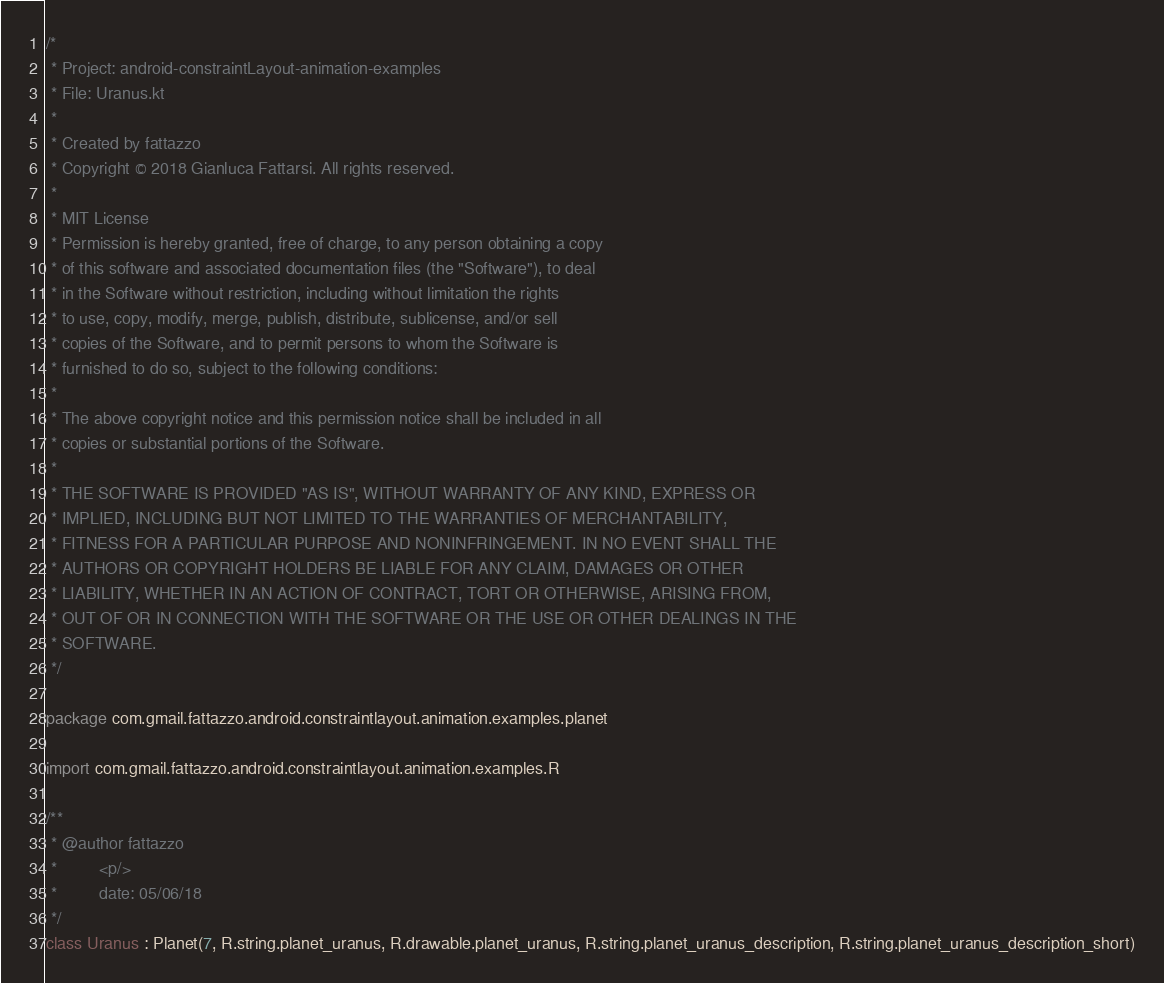Convert code to text. <code><loc_0><loc_0><loc_500><loc_500><_Kotlin_>/*
 * Project: android-constraintLayout-animation-examples
 * File: Uranus.kt
 *
 * Created by fattazzo
 * Copyright © 2018 Gianluca Fattarsi. All rights reserved.
 *
 * MIT License
 * Permission is hereby granted, free of charge, to any person obtaining a copy
 * of this software and associated documentation files (the "Software"), to deal
 * in the Software without restriction, including without limitation the rights
 * to use, copy, modify, merge, publish, distribute, sublicense, and/or sell
 * copies of the Software, and to permit persons to whom the Software is
 * furnished to do so, subject to the following conditions:
 *
 * The above copyright notice and this permission notice shall be included in all
 * copies or substantial portions of the Software.
 *
 * THE SOFTWARE IS PROVIDED "AS IS", WITHOUT WARRANTY OF ANY KIND, EXPRESS OR
 * IMPLIED, INCLUDING BUT NOT LIMITED TO THE WARRANTIES OF MERCHANTABILITY,
 * FITNESS FOR A PARTICULAR PURPOSE AND NONINFRINGEMENT. IN NO EVENT SHALL THE
 * AUTHORS OR COPYRIGHT HOLDERS BE LIABLE FOR ANY CLAIM, DAMAGES OR OTHER
 * LIABILITY, WHETHER IN AN ACTION OF CONTRACT, TORT OR OTHERWISE, ARISING FROM,
 * OUT OF OR IN CONNECTION WITH THE SOFTWARE OR THE USE OR OTHER DEALINGS IN THE
 * SOFTWARE.
 */

package com.gmail.fattazzo.android.constraintlayout.animation.examples.planet

import com.gmail.fattazzo.android.constraintlayout.animation.examples.R

/**
 * @author fattazzo
 *         <p/>
 *         date: 05/06/18
 */
class Uranus : Planet(7, R.string.planet_uranus, R.drawable.planet_uranus, R.string.planet_uranus_description, R.string.planet_uranus_description_short)</code> 